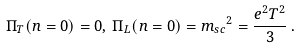<formula> <loc_0><loc_0><loc_500><loc_500>\Pi _ { T } ( n = 0 ) = 0 , \, \Pi _ { L } ( n = 0 ) = { m _ { s c } } ^ { 2 } = \frac { e ^ { 2 } T ^ { 2 } } { 3 } \, .</formula> 